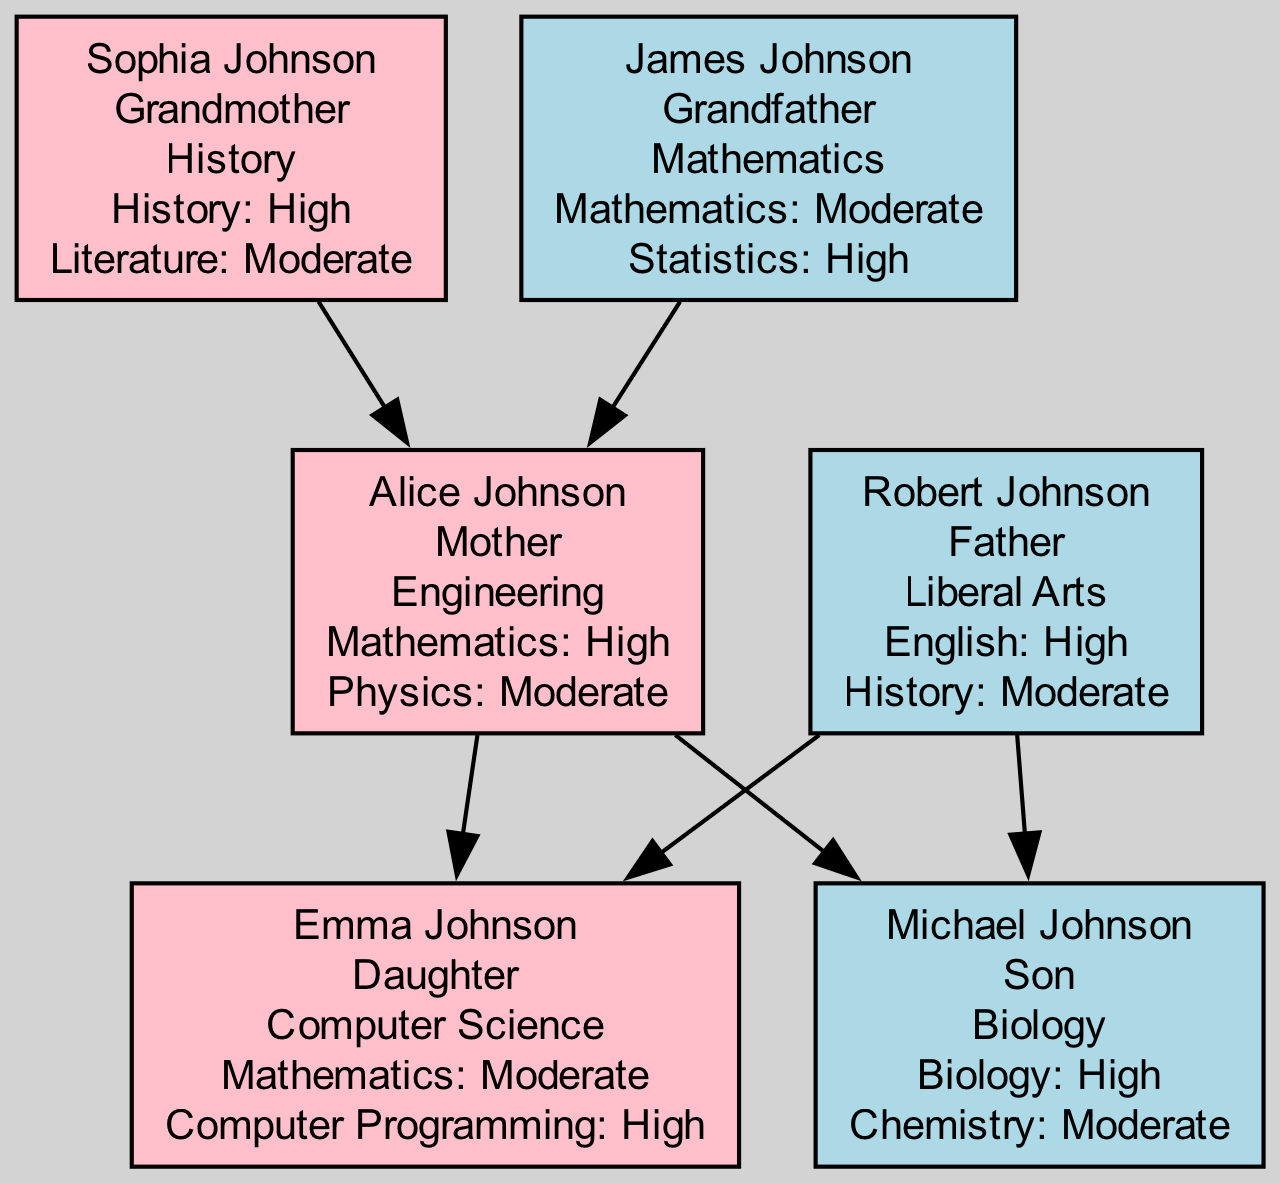What is the field of study for Alice Johnson? In the diagram, each family member is labeled with their name and field of study. Alice Johnson's field of study is clearly stated under her name in the diagram.
Answer: Engineering How many children does Alice Johnson have? To determine the number of children Alice Johnson has, we look at the connections leading from her node. There are two edges leading to Emma Johnson and Michael Johnson, indicating she has two children.
Answer: 2 What is Michael Johnson's performance in Biology under stereotype threat? Each family member's subject performance under threat is detailed in their respective sections. For Michael Johnson, the performance in Biology is mentioned directly below his name.
Answer: High Who is the grandfather of Emma Johnson? To find Emma Johnson's grandfather, we trace back the family tree. She is the daughter of Alice Johnson and Robert Johnson, whose parents are James Johnson (grandfather) and Sophia Johnson (grandmother).
Answer: James Johnson Which subjects does Sophia Johnson have moderate performance in? Sophia Johnson's performance data is listed under her node. The subjects listed with moderate performance are noted clearly for reference.
Answer: Literature What is the relationship between Robert Johnson and Michael Johnson? Robert Johnson is the father of Michael Johnson, as reflected in the diagram's edges connecting their nodes, specifically showing a direct lineage from Robert to Michael.
Answer: Father-Son How many family members are female? To find the number of female family members, we can count each node designated as female. There are four female members shown: Alice Johnson, Emma Johnson, Sophia Johnson.
Answer: 3 Which family member has a high performance in Computer Programming? Looking through the diagram, we can find that Emma Johnson's performance details show a high performance specifically in Computer Programming, which is clearly indicated below her name.
Answer: Emma Johnson What role does James Johnson play in the family? By checking the label for James Johnson in the diagram, we see that he is categorized as the grandfather, a term which clarifies his familial role.
Answer: Grandfather 